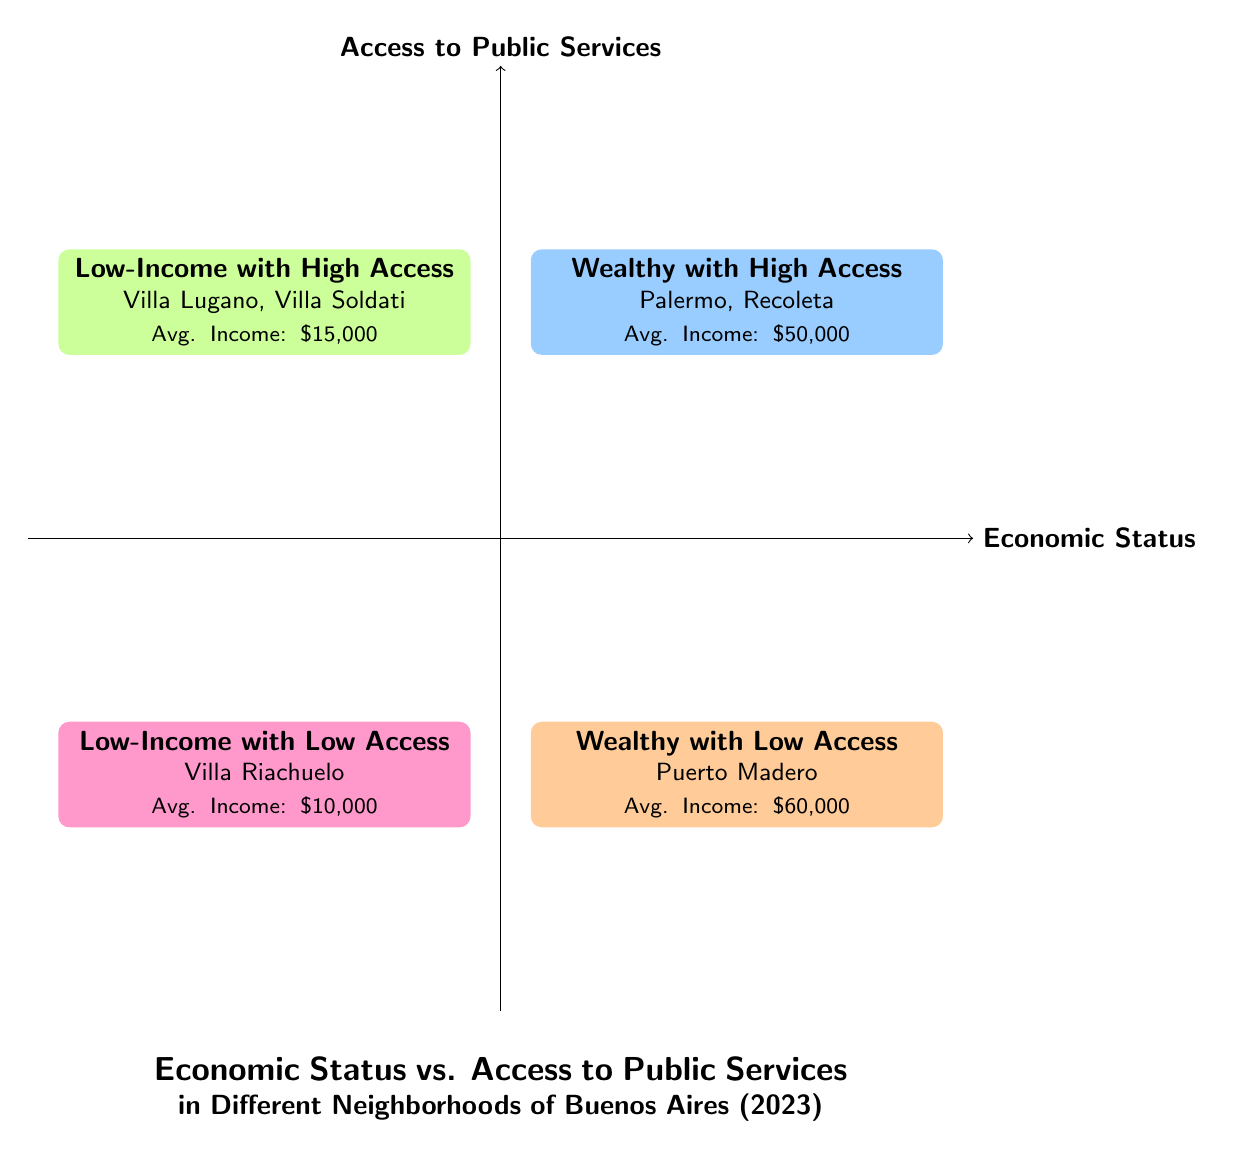What neighborhoods are classified as wealthy with high access? The quadrant labeled "Wealthy with High Access" lists the neighborhoods Palermo and Recoleta.
Answer: Palermo, Recoleta What is the average income of residents in Villa Riachuelo? Villa Riachuelo is in the "Low-Income with Low Access" quadrant, which indicates an average income of $10,000.
Answer: $10,000 Which quadrant has the highest average income? The "Wealthy with Low Access" quadrant has the highest average income at $60,000, as compared to other quadrants.
Answer: $60,000 How many neighborhoods are classified as low-income with high access? The "Low-Income with High Access" quadrant contains two neighborhoods: Villa Lugano and Villa Soldati. Therefore, the count is 2.
Answer: 2 What is a characteristic of public services in Puerto Madero? The characteristics under the "Wealthy with Low Access" quadrant for Puerto Madero mention "Limited public schools."
Answer: Limited public schools Which neighborhood has the lowest average income? The neighborhood in the "Low-Income with Low Access" quadrant, Villa Riachuelo, has the lowest average income of $10,000.
Answer: Villa Riachuelo What type of healthcare services are available in Villa Soldati? Villa Soldati, under the "Low-Income with High Access," has "Basic healthcare facilities" as a characteristic of its public services.
Answer: Basic healthcare facilities In which quadrant would you find neighborhoods with advanced public transportation? The "Wealthy with High Access" quadrant, which includes Palermo and Recoleta, lists advanced public transportation as a service characteristic.
Answer: Wealthy with High Access 